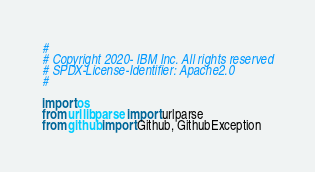<code> <loc_0><loc_0><loc_500><loc_500><_Python_>#
# Copyright 2020- IBM Inc. All rights reserved
# SPDX-License-Identifier: Apache2.0
#

import os
from urllib.parse import urlparse
from github import Github, GithubException</code> 